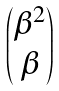<formula> <loc_0><loc_0><loc_500><loc_500>\begin{pmatrix} \beta ^ { 2 } \\ \beta \end{pmatrix}</formula> 